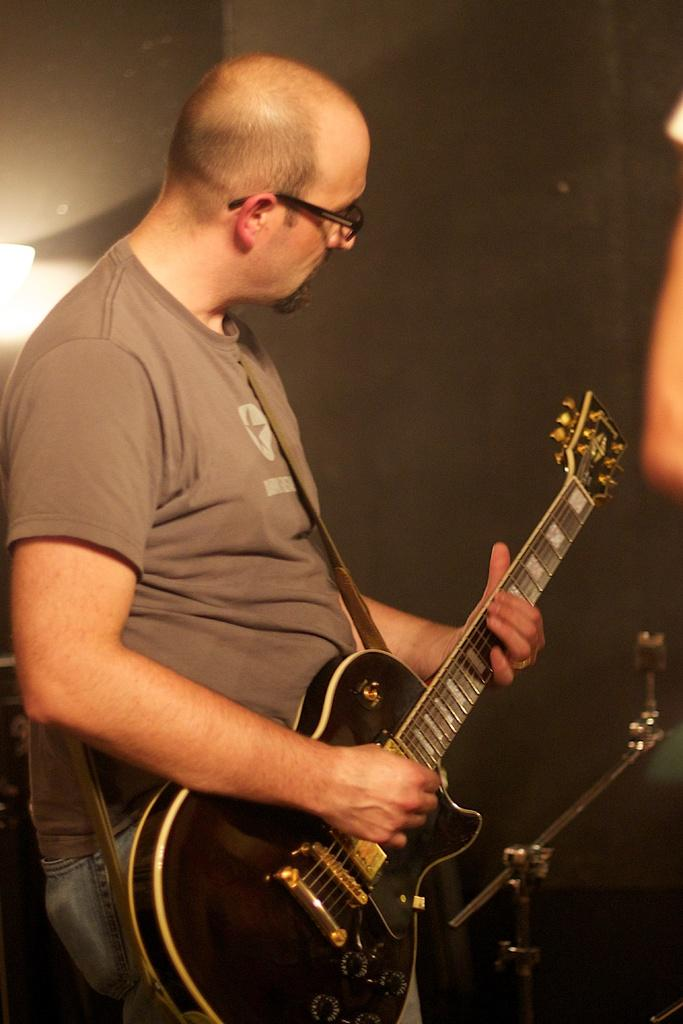What is the main subject of the image? The main subject of the image is a man. What is the man wearing in the image? The man is wearing spectacles in the image. What is the man doing in the image? The man is playing a guitar in the image. How many ducks are visible in the image? There are no ducks present in the image. What type of clam is the man holding while playing the guitar? There is no clam present in the image; the man is playing a guitar. 